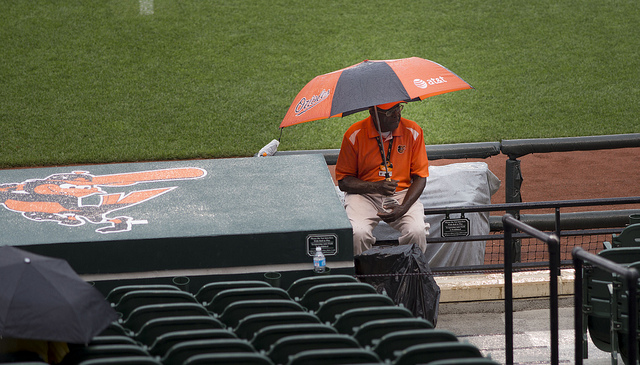What color is the umpire's seat? The umpire's seat in the image is green, blending with the overall color scheme of the stadium seating area. 